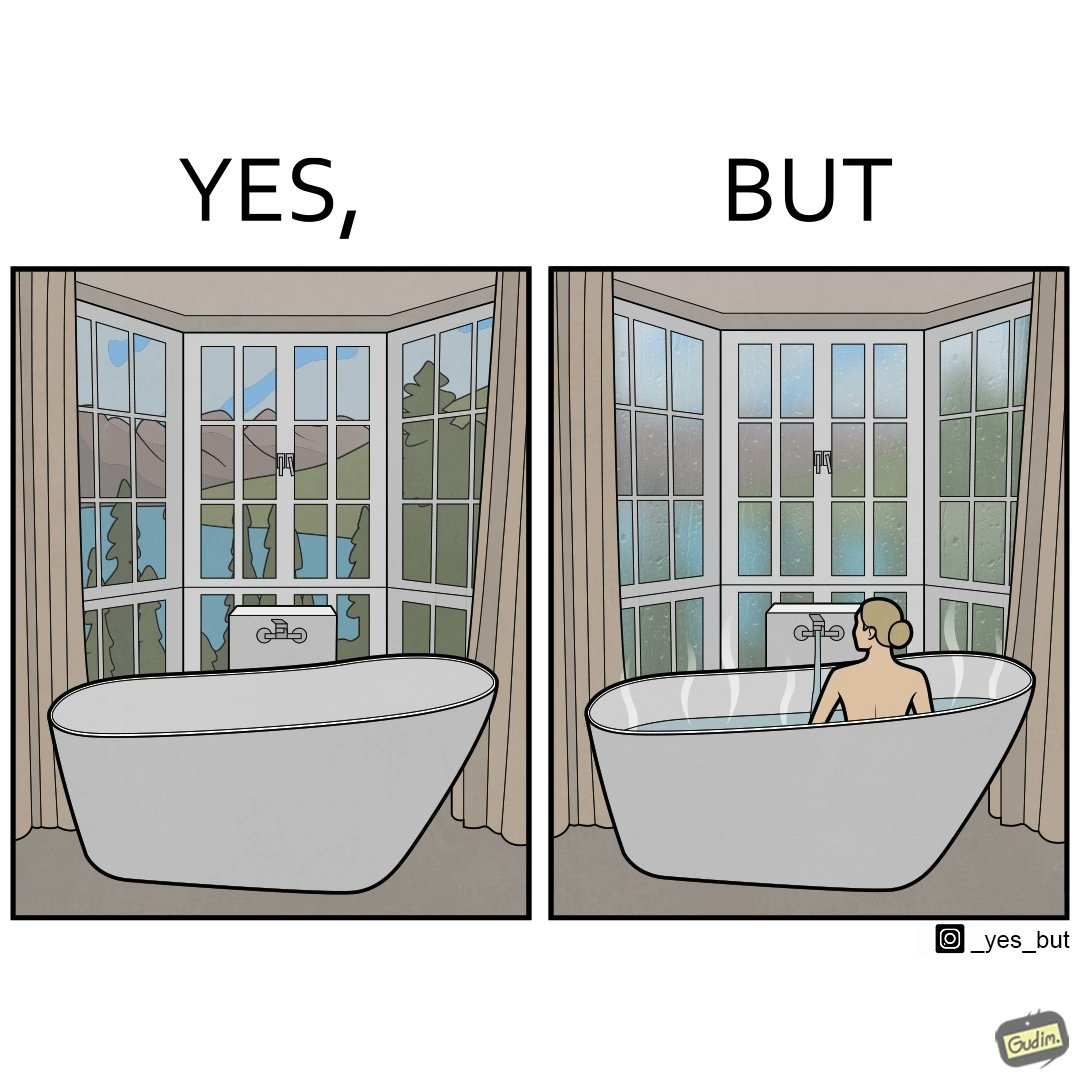What do you see in each half of this image? In the left part of the image: a bathtub by the side of a window which has a very scenic view of lake and mountains. In the right part of the image: a woman bathing in a bathtub, while the window glasses are foggy from the steam of the hot water. 